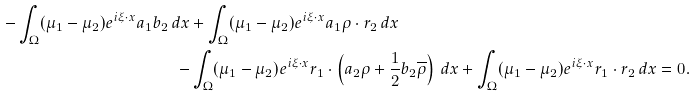<formula> <loc_0><loc_0><loc_500><loc_500>- \int _ { \Omega } ( \mu _ { 1 } - \mu _ { 2 } ) e ^ { i \xi \cdot x } a _ { 1 } b _ { 2 } \, d x & + \int _ { \Omega } ( \mu _ { 1 } - \mu _ { 2 } ) e ^ { i \xi \cdot x } a _ { 1 } \rho \cdot r _ { 2 } \, d x \\ - & \int _ { \Omega } ( \mu _ { 1 } - \mu _ { 2 } ) e ^ { i \xi \cdot x } r _ { 1 } \cdot \left ( a _ { 2 } \rho + \frac { 1 } { 2 } b _ { 2 } \overline { \rho } \right ) \, d x + \int _ { \Omega } ( \mu _ { 1 } - \mu _ { 2 } ) e ^ { i \xi \cdot x } r _ { 1 } \cdot r _ { 2 } \, d x = 0 .</formula> 